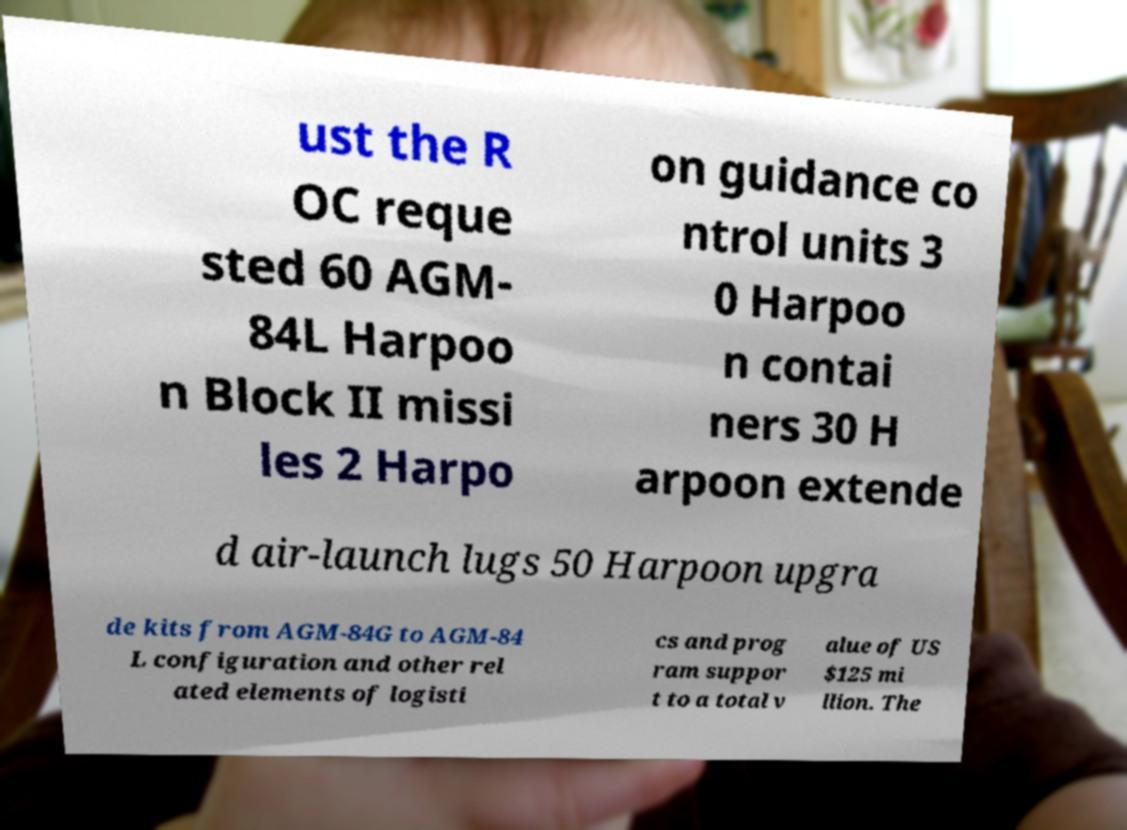Could you extract and type out the text from this image? ust the R OC reque sted 60 AGM- 84L Harpoo n Block II missi les 2 Harpo on guidance co ntrol units 3 0 Harpoo n contai ners 30 H arpoon extende d air-launch lugs 50 Harpoon upgra de kits from AGM-84G to AGM-84 L configuration and other rel ated elements of logisti cs and prog ram suppor t to a total v alue of US $125 mi llion. The 